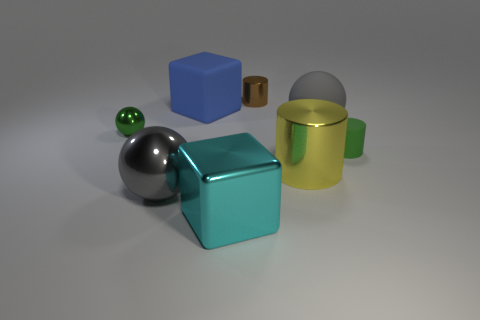There is a metal sphere that is the same color as the matte ball; what is its size?
Your response must be concise. Large. There is a big object that is in front of the big gray metallic ball; what is its shape?
Your answer should be very brief. Cube. Are there fewer cyan shiny blocks behind the big blue cube than small things behind the tiny green ball?
Provide a short and direct response. Yes. There is a green matte cylinder; is it the same size as the gray thing in front of the yellow metallic object?
Keep it short and to the point. No. What number of rubber things have the same size as the brown cylinder?
Make the answer very short. 1. There is a small sphere that is the same material as the brown thing; what color is it?
Your response must be concise. Green. Is the number of large matte blocks greater than the number of small brown blocks?
Ensure brevity in your answer.  Yes. Are the green cylinder and the big blue object made of the same material?
Your answer should be compact. Yes. What is the shape of the brown thing that is the same material as the yellow thing?
Ensure brevity in your answer.  Cylinder. Are there fewer tiny shiny balls than shiny balls?
Your answer should be compact. Yes. 